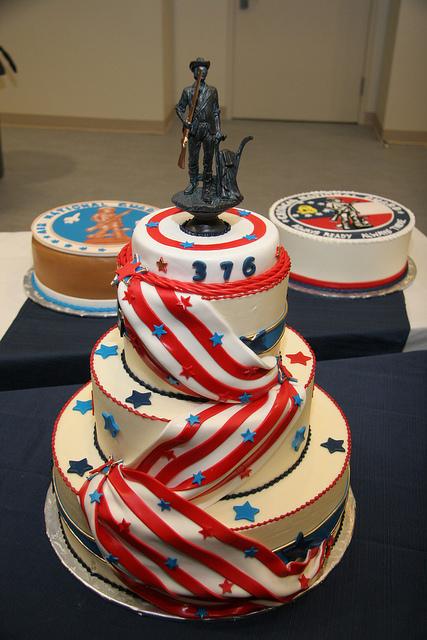What number in blue is on the cake?
Short answer required. 376. What type of cake is this?
Quick response, please. 4th of july. What colors are the cake?
Give a very brief answer. Red white and blue. 